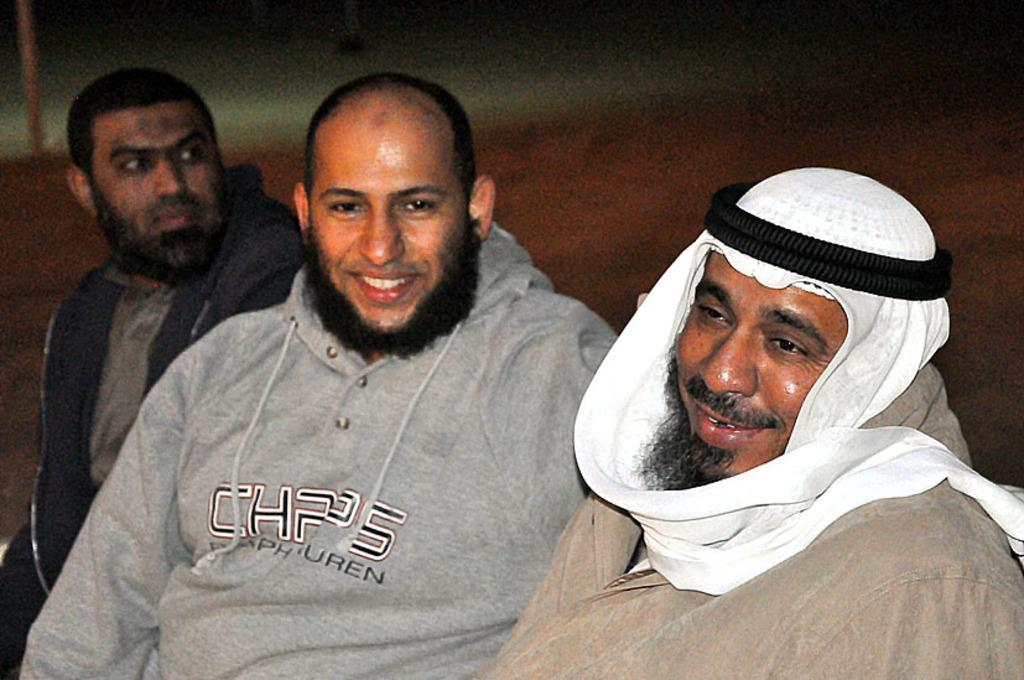How many people are in the image? There are three men in the image. What are the men doing in the image? The men are sitting. What are the men wearing in the image? The men are wearing jackets. Can you describe the appearance of one of the men in the image? One man has a cloth tied around his neck. What type of rod is the mother using to pet the men in the image? There is no mention of a mother, rod, or pet in the image. The image features three men sitting and wearing jackets, with one man having a cloth tied around his neck. 